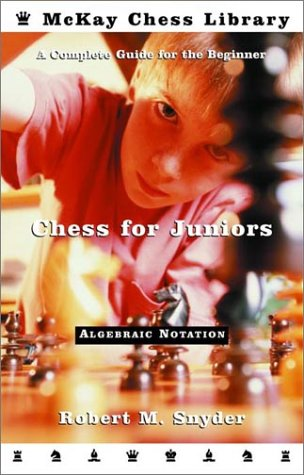Who might be the target audience for this book, based on the cover image? The target audience is likely young chess enthusiasts or beginners. The cover, depicting a child deeply engrossed in a chess game, aligns well with the book's content which is meant to guide novice players. 